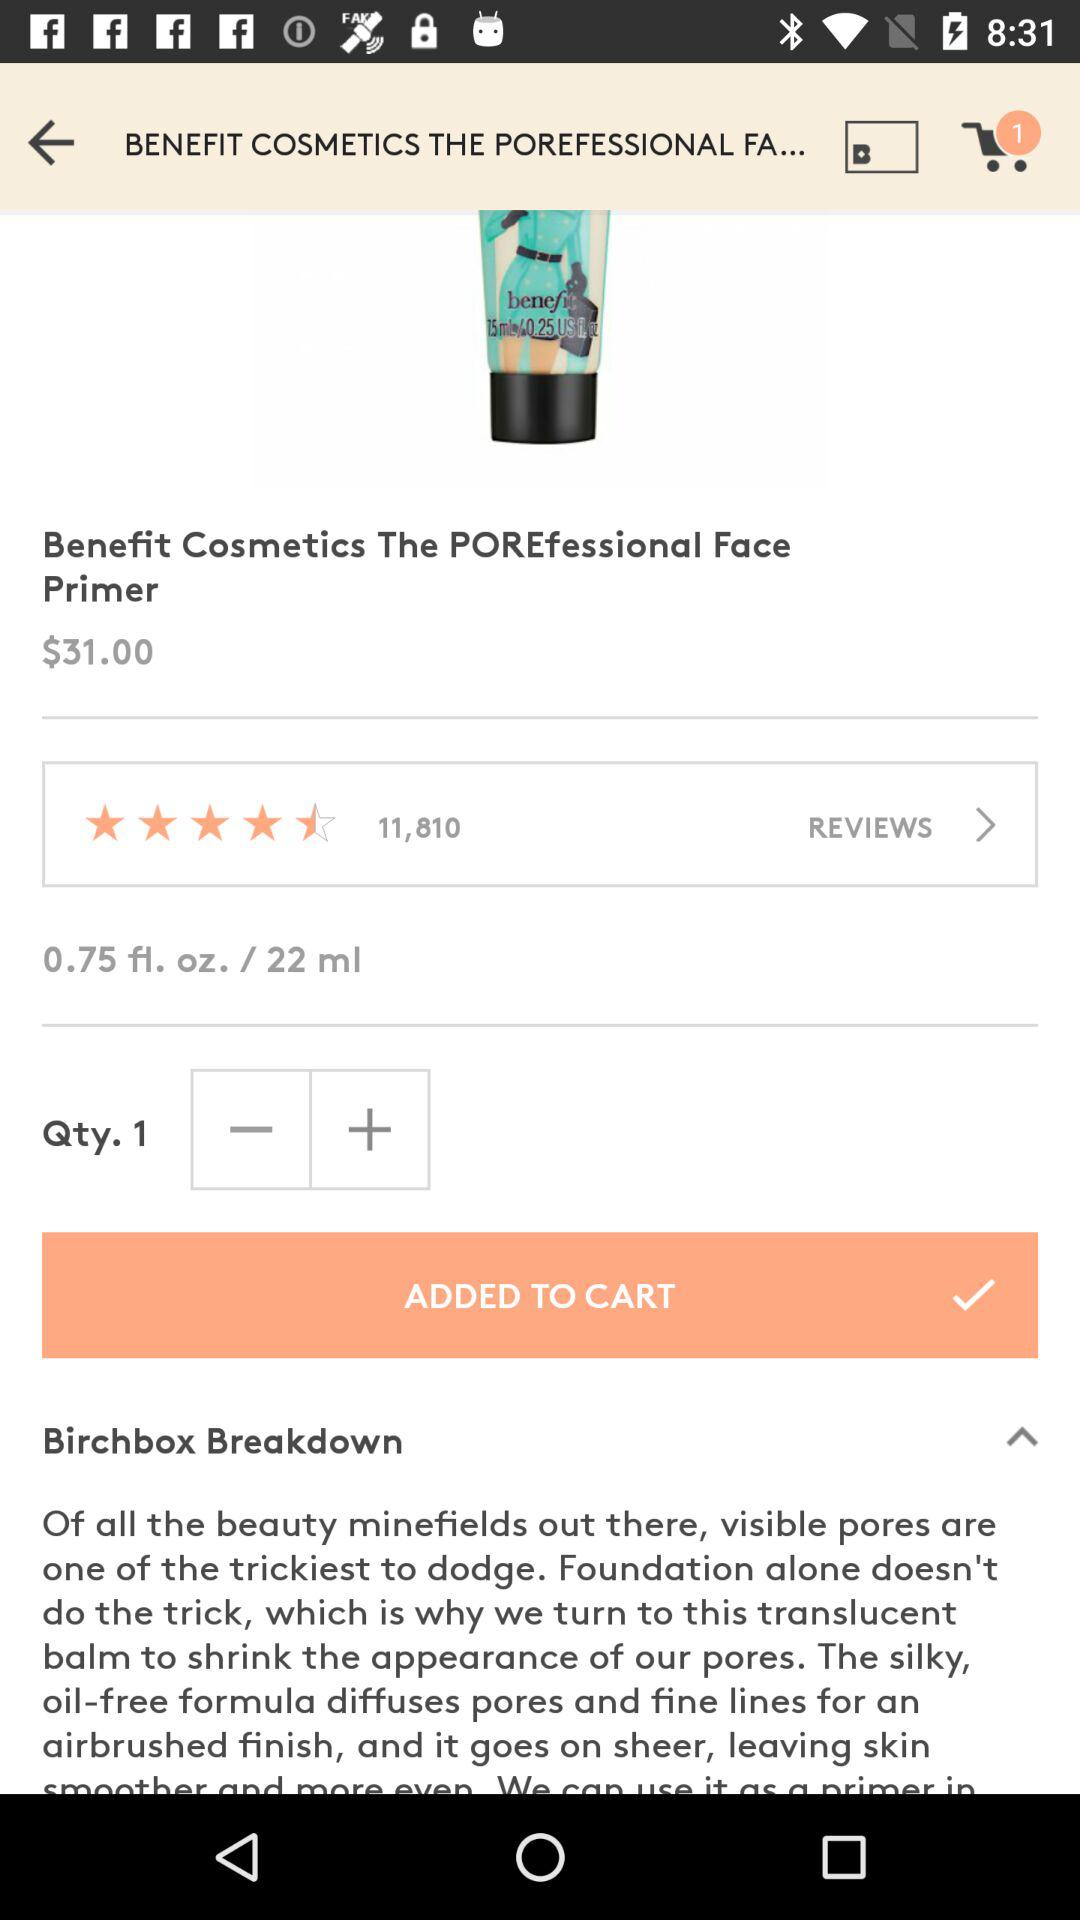How many stars are given to the product? There are 4.5 stars given to the product. 